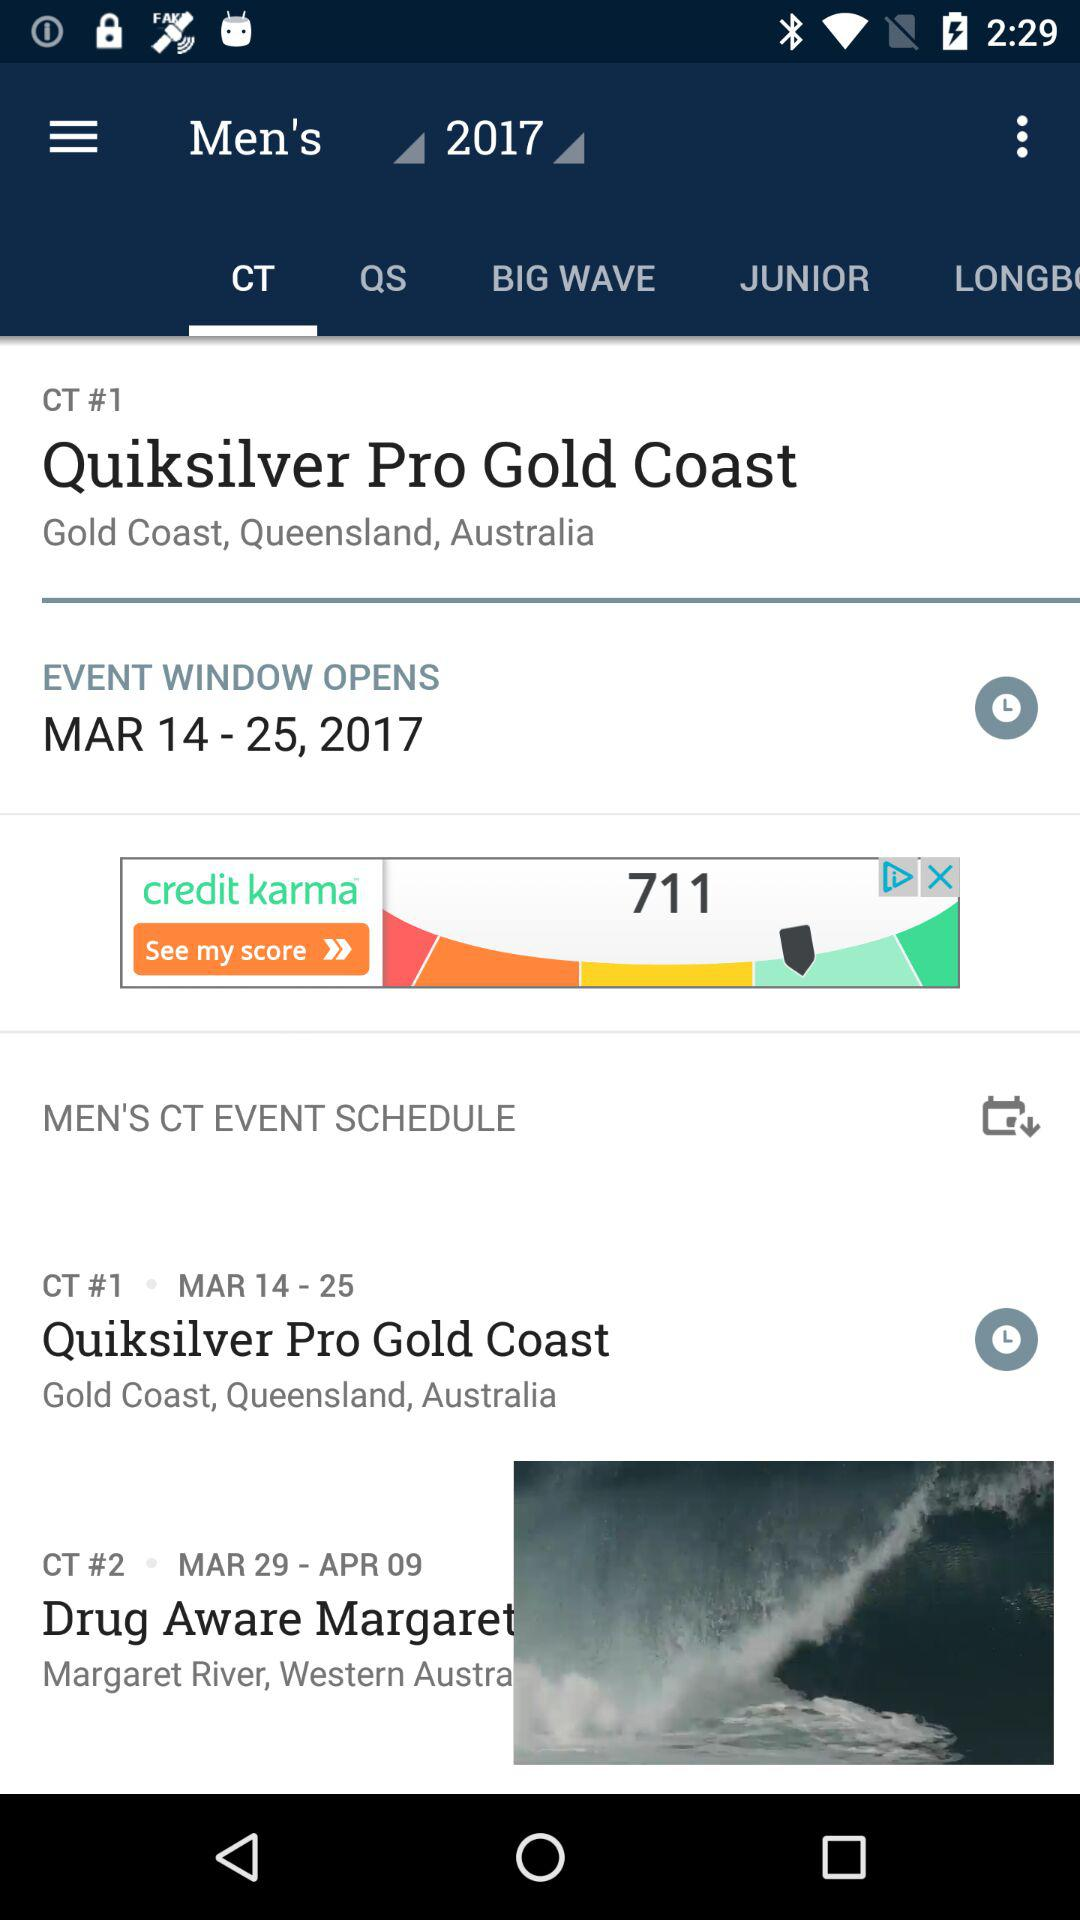Which tab is selected? The selected tab is "CT". 